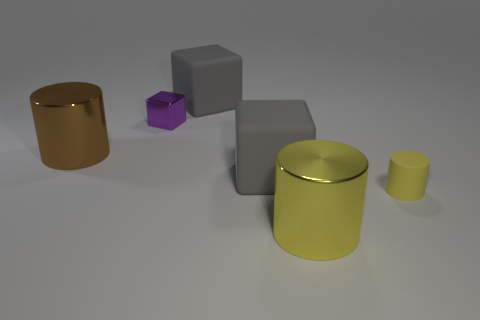What is the size of the brown metal thing? The brown cylindrical object appears to be medium-sized in relation to the other items in the image, which include various geometric shapes like cubes and cylinders of different sizes and colors. 